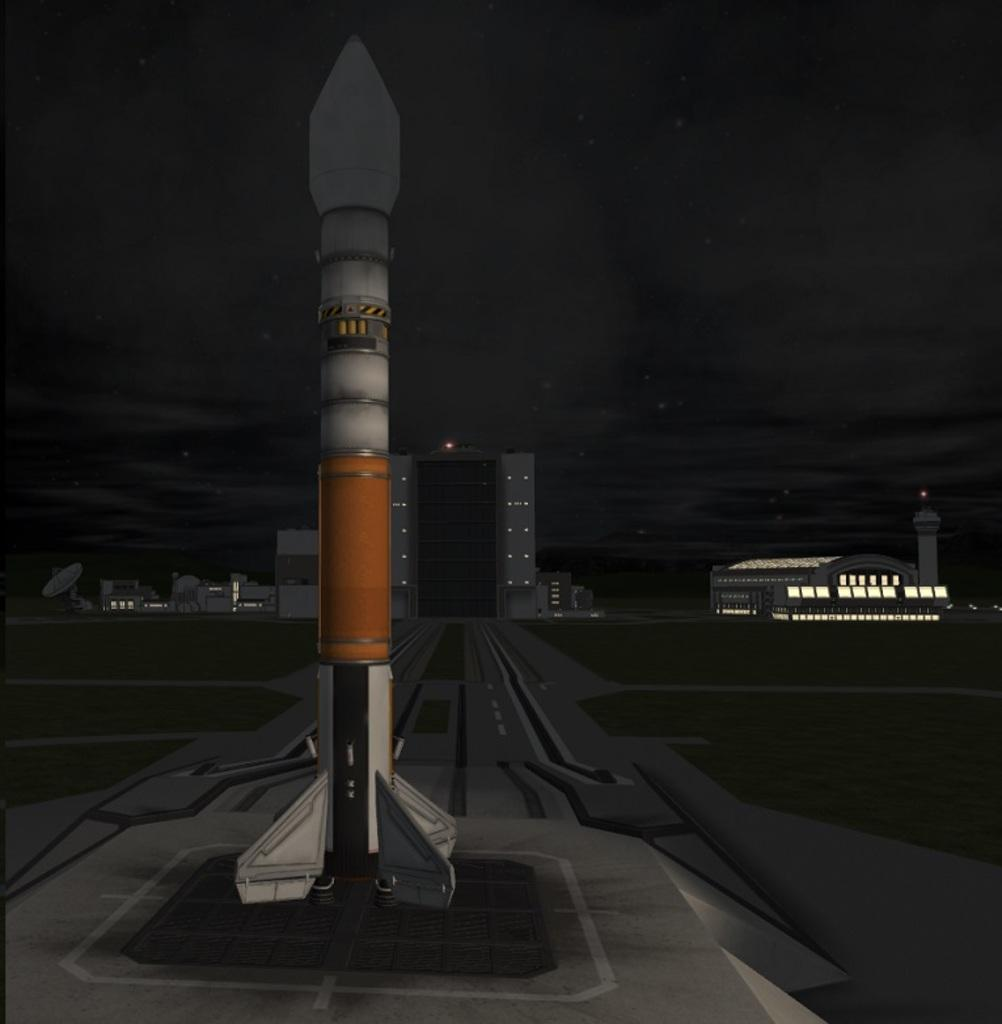What is the main subject of the image? The main subject of the image is a missile. What can be seen in the background of the image? There are buildings in the background of the image. What part of the natural environment is visible in the image? The sky is visible in the image. What type of soda is being served at the creature's approval in the image? There is no soda or creature present in the image; it features a missile and buildings in the background. 